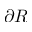<formula> <loc_0><loc_0><loc_500><loc_500>\partial R</formula> 